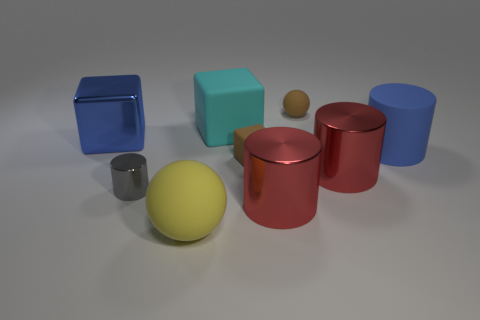How many objects are large things that are right of the large blue metal object or large rubber blocks?
Provide a succinct answer. 5. What size is the shiny block that is the same color as the matte cylinder?
Provide a short and direct response. Large. There is a matte cube in front of the blue shiny object; does it have the same color as the tiny object behind the blue rubber cylinder?
Keep it short and to the point. Yes. What is the size of the brown matte block?
Offer a very short reply. Small. What number of tiny things are yellow rubber balls or brown rubber blocks?
Make the answer very short. 1. The rubber block that is the same size as the yellow rubber object is what color?
Give a very brief answer. Cyan. How many other objects are there of the same shape as the cyan thing?
Offer a terse response. 2. Are there any brown balls that have the same material as the big yellow ball?
Offer a terse response. Yes. Are the blue thing that is left of the big blue matte thing and the small object left of the large cyan rubber thing made of the same material?
Give a very brief answer. Yes. How many big rubber things are there?
Your response must be concise. 3. 